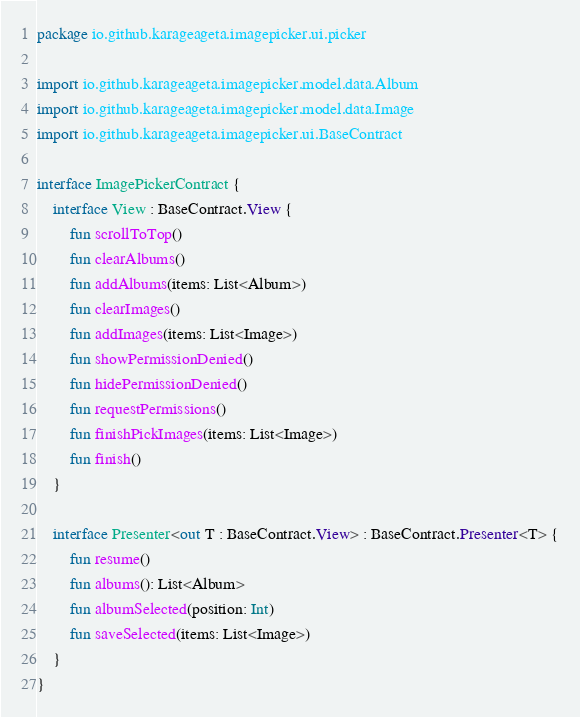Convert code to text. <code><loc_0><loc_0><loc_500><loc_500><_Kotlin_>package io.github.karageageta.imagepicker.ui.picker

import io.github.karageageta.imagepicker.model.data.Album
import io.github.karageageta.imagepicker.model.data.Image
import io.github.karageageta.imagepicker.ui.BaseContract

interface ImagePickerContract {
    interface View : BaseContract.View {
        fun scrollToTop()
        fun clearAlbums()
        fun addAlbums(items: List<Album>)
        fun clearImages()
        fun addImages(items: List<Image>)
        fun showPermissionDenied()
        fun hidePermissionDenied()
        fun requestPermissions()
        fun finishPickImages(items: List<Image>)
        fun finish()
    }

    interface Presenter<out T : BaseContract.View> : BaseContract.Presenter<T> {
        fun resume()
        fun albums(): List<Album>
        fun albumSelected(position: Int)
        fun saveSelected(items: List<Image>)
    }
}
</code> 